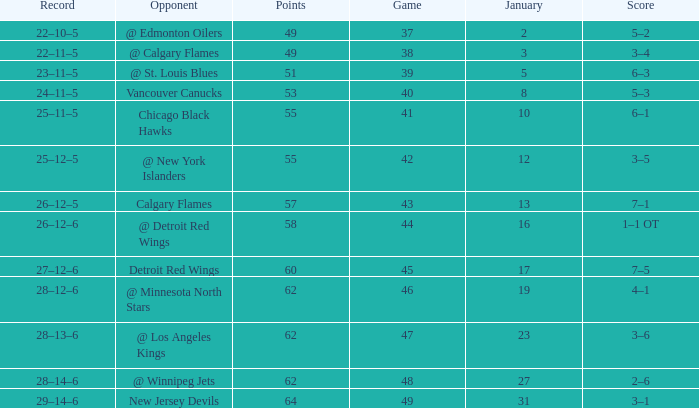How much January has a Record of 26–12–6, and Points smaller than 58? None. 